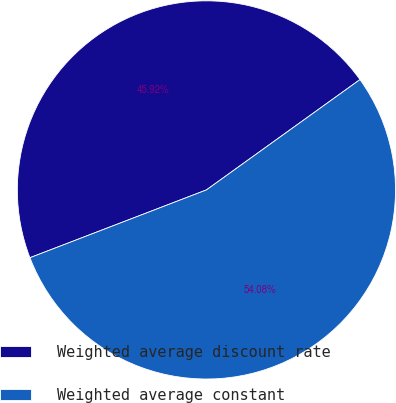Convert chart. <chart><loc_0><loc_0><loc_500><loc_500><pie_chart><fcel>Weighted average discount rate<fcel>Weighted average constant<nl><fcel>45.92%<fcel>54.08%<nl></chart> 